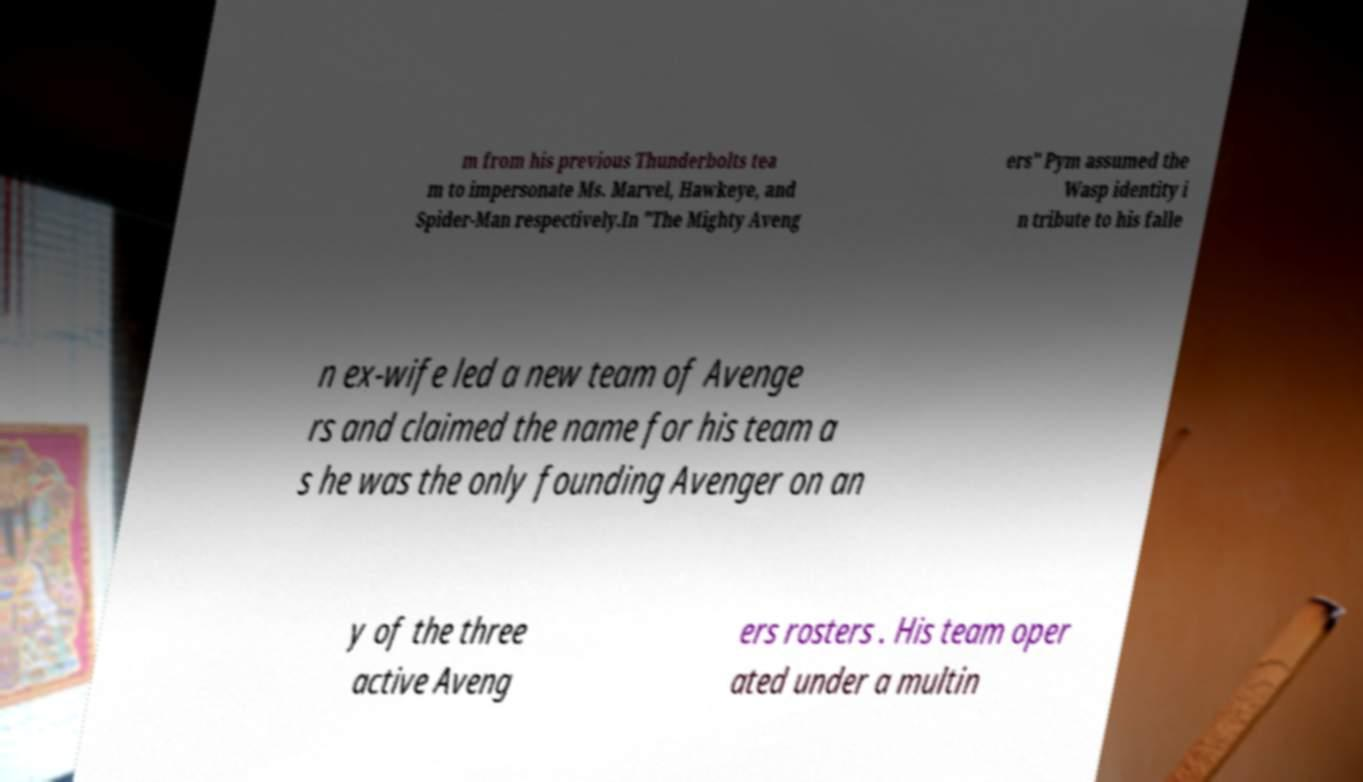Please read and relay the text visible in this image. What does it say? m from his previous Thunderbolts tea m to impersonate Ms. Marvel, Hawkeye, and Spider-Man respectively.In "The Mighty Aveng ers" Pym assumed the Wasp identity i n tribute to his falle n ex-wife led a new team of Avenge rs and claimed the name for his team a s he was the only founding Avenger on an y of the three active Aveng ers rosters . His team oper ated under a multin 